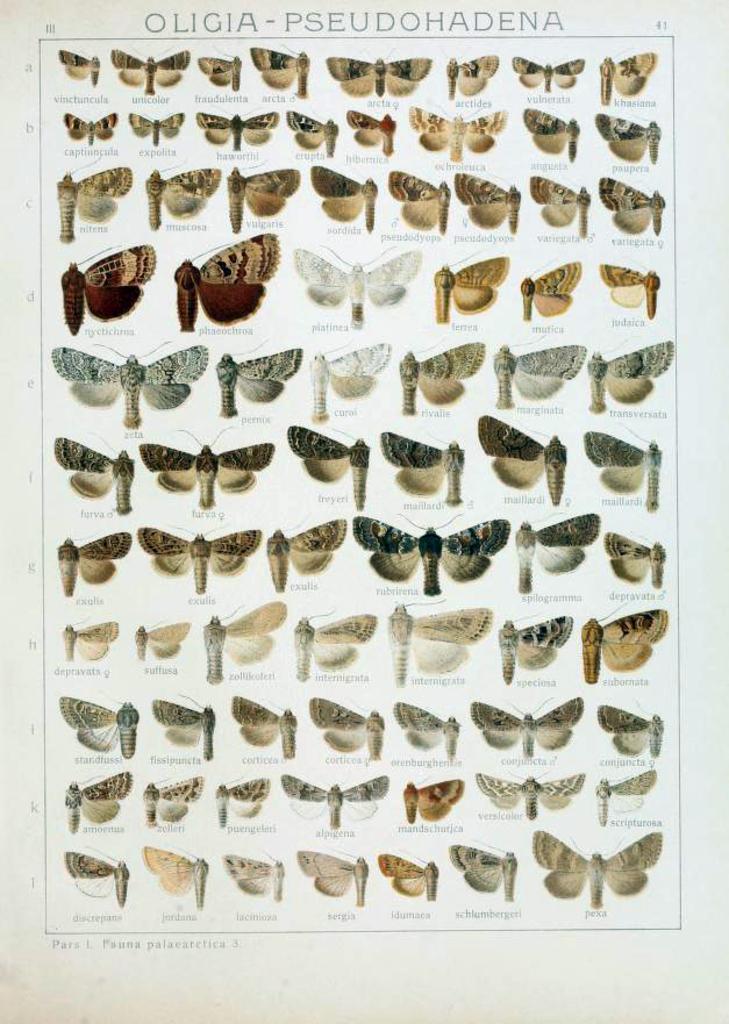Describe this image in one or two sentences. In this image we can see a group of photos of butterflies and some text on it. 